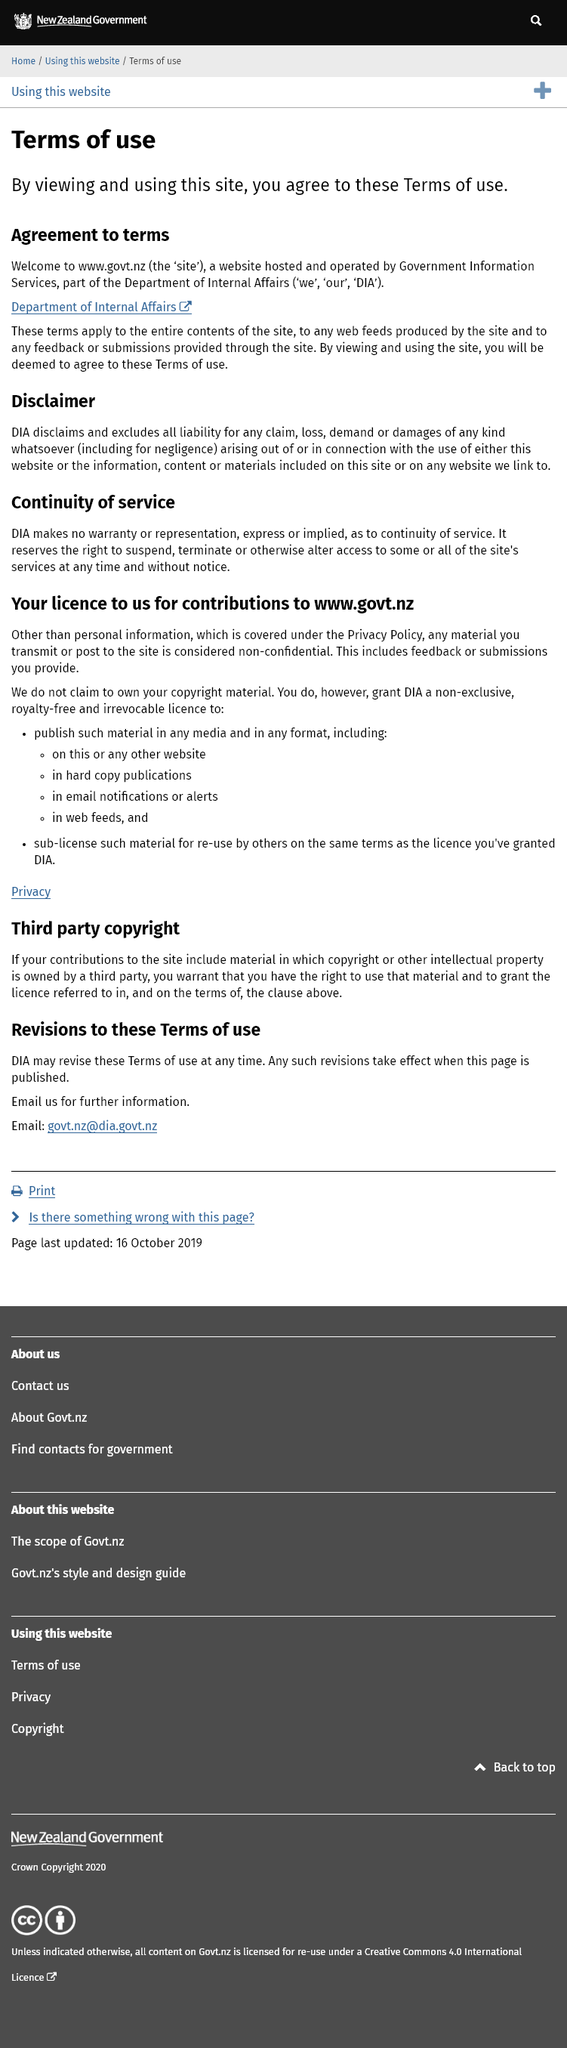Identify some key points in this picture. By viewing and using this site, you agree to the terms of use as stated in our terms of service. The website is hosted and operated by the Government Information Services, which is a part of the Department of Internal Affairs. The website that I am currently viewing is [www.govt.nz](http://www.govt.nz). 